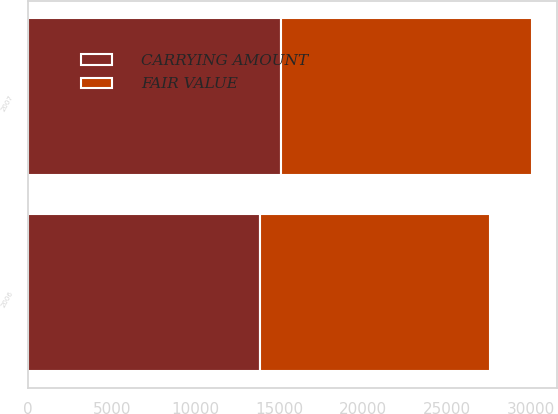<chart> <loc_0><loc_0><loc_500><loc_500><stacked_bar_chart><ecel><fcel>2007<fcel>2006<nl><fcel>CARRYING AMOUNT<fcel>15095<fcel>13824<nl><fcel>FAIR VALUE<fcel>14931<fcel>13702<nl></chart> 